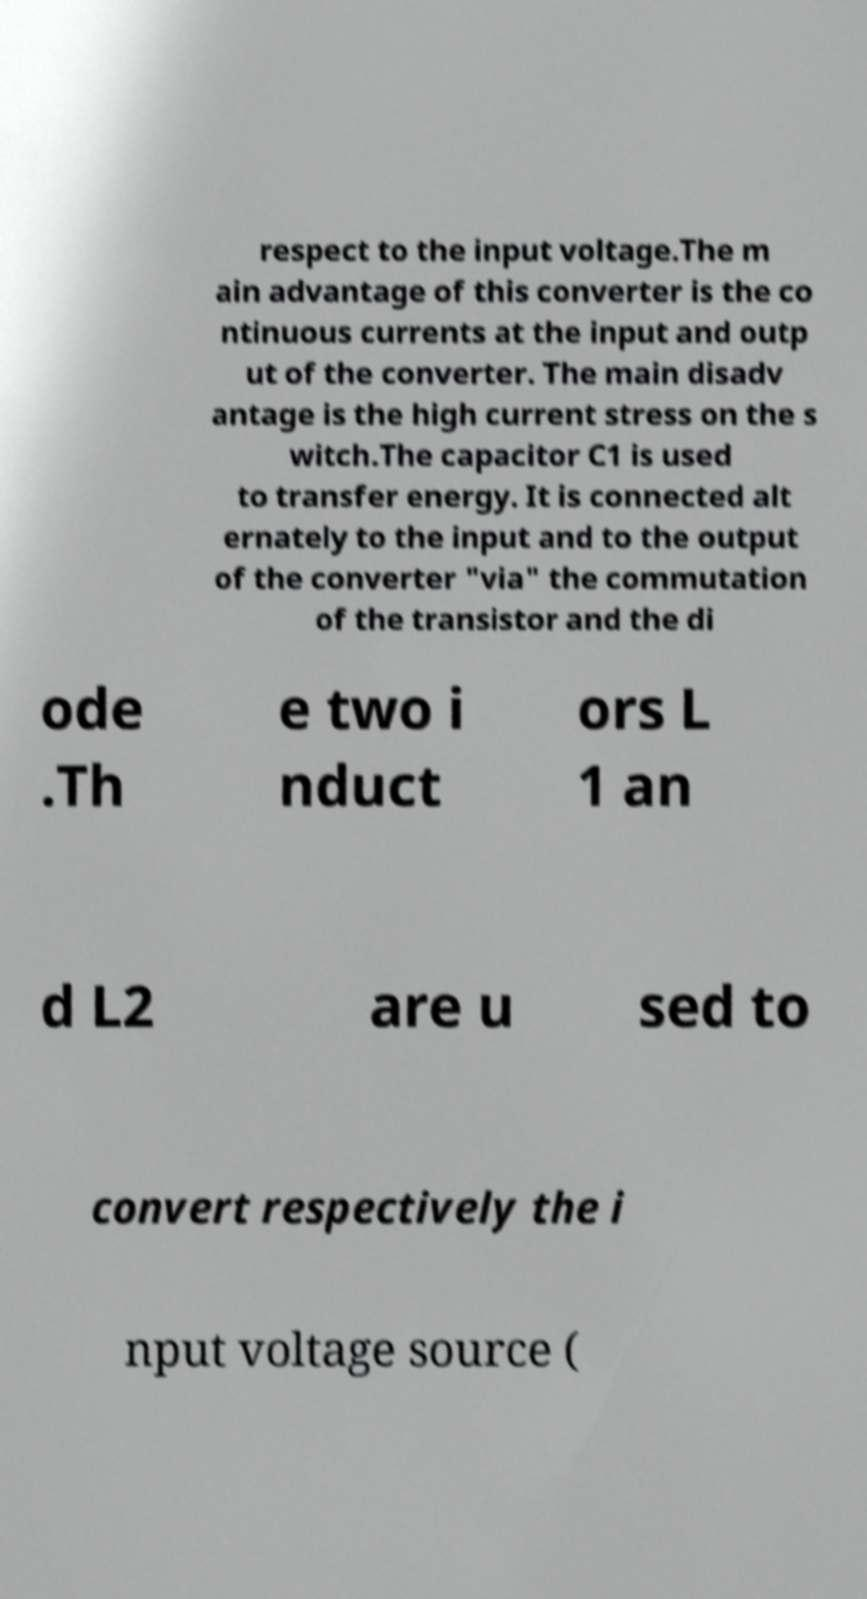Can you read and provide the text displayed in the image?This photo seems to have some interesting text. Can you extract and type it out for me? respect to the input voltage.The m ain advantage of this converter is the co ntinuous currents at the input and outp ut of the converter. The main disadv antage is the high current stress on the s witch.The capacitor C1 is used to transfer energy. It is connected alt ernately to the input and to the output of the converter "via" the commutation of the transistor and the di ode .Th e two i nduct ors L 1 an d L2 are u sed to convert respectively the i nput voltage source ( 